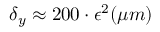<formula> <loc_0><loc_0><loc_500><loc_500>\delta _ { y } \approx 2 0 0 \cdot \epsilon ^ { 2 } ( \mu m )</formula> 